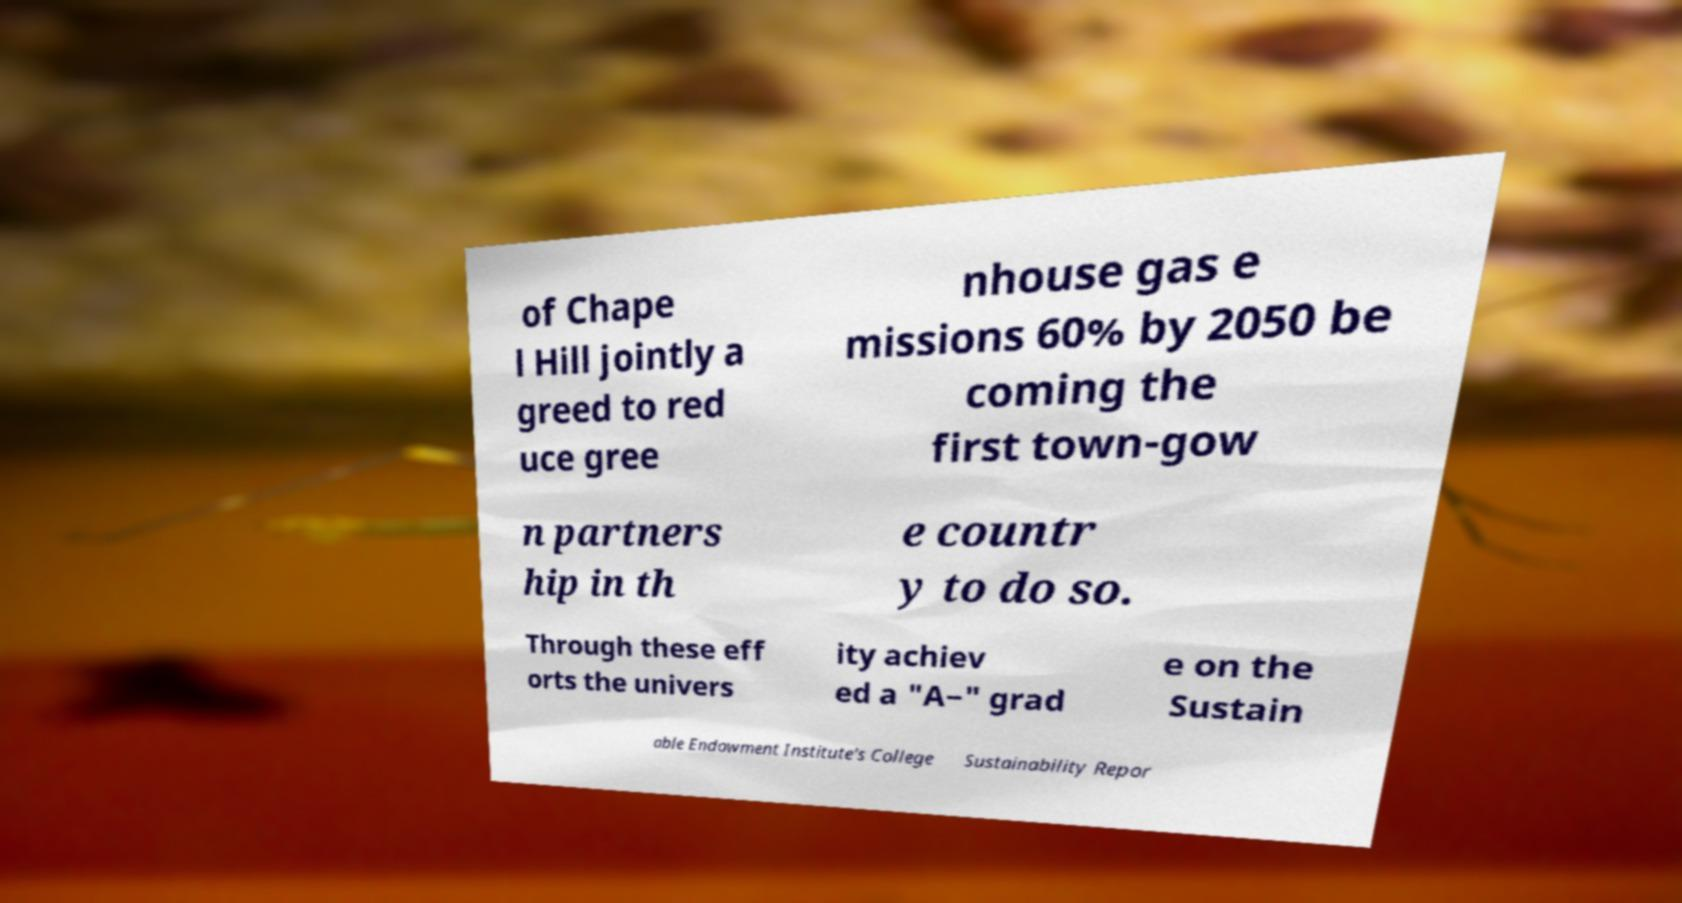I need the written content from this picture converted into text. Can you do that? of Chape l Hill jointly a greed to red uce gree nhouse gas e missions 60% by 2050 be coming the first town-gow n partners hip in th e countr y to do so. Through these eff orts the univers ity achiev ed a "A−" grad e on the Sustain able Endowment Institute's College Sustainability Repor 